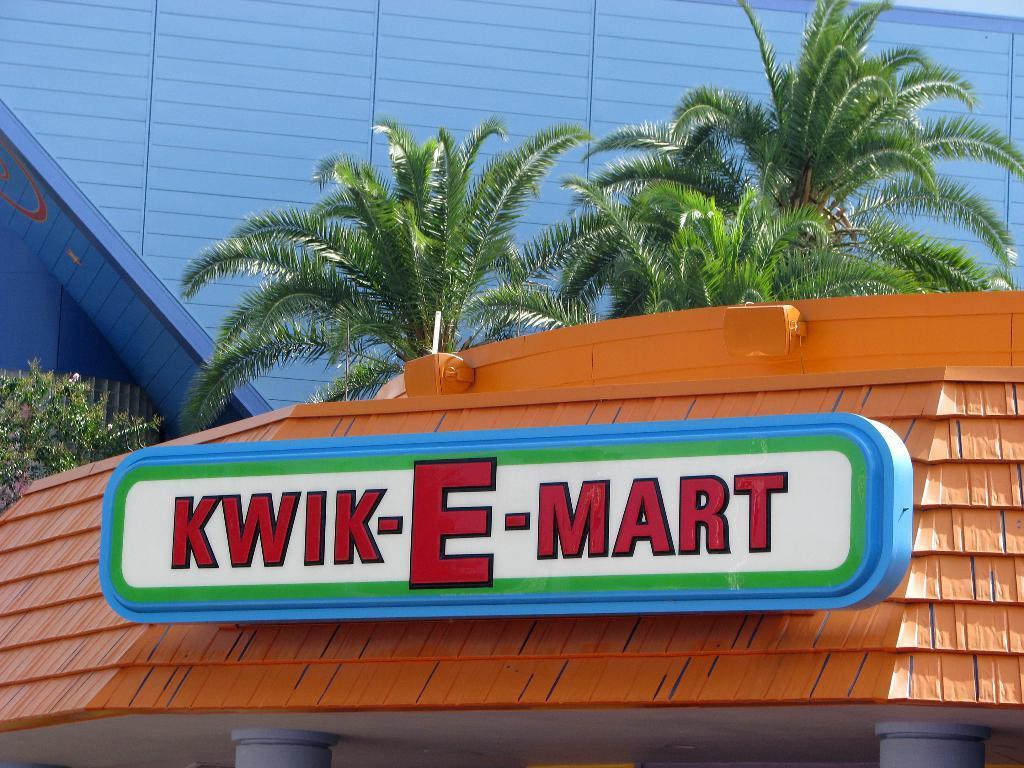In one or two sentences, can you explain what this image depicts? In this picture I can observe board in the middle of the picture. In the background I can observe trees and buildings. 